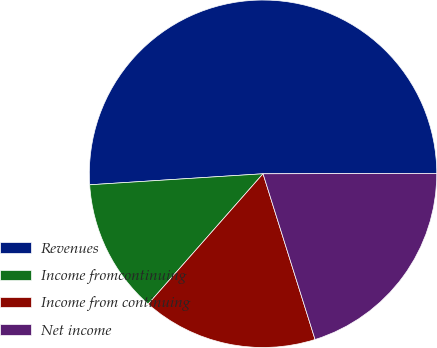<chart> <loc_0><loc_0><loc_500><loc_500><pie_chart><fcel>Revenues<fcel>Income fromcontinuing<fcel>Income from continuing<fcel>Net income<nl><fcel>50.98%<fcel>12.49%<fcel>16.34%<fcel>20.19%<nl></chart> 